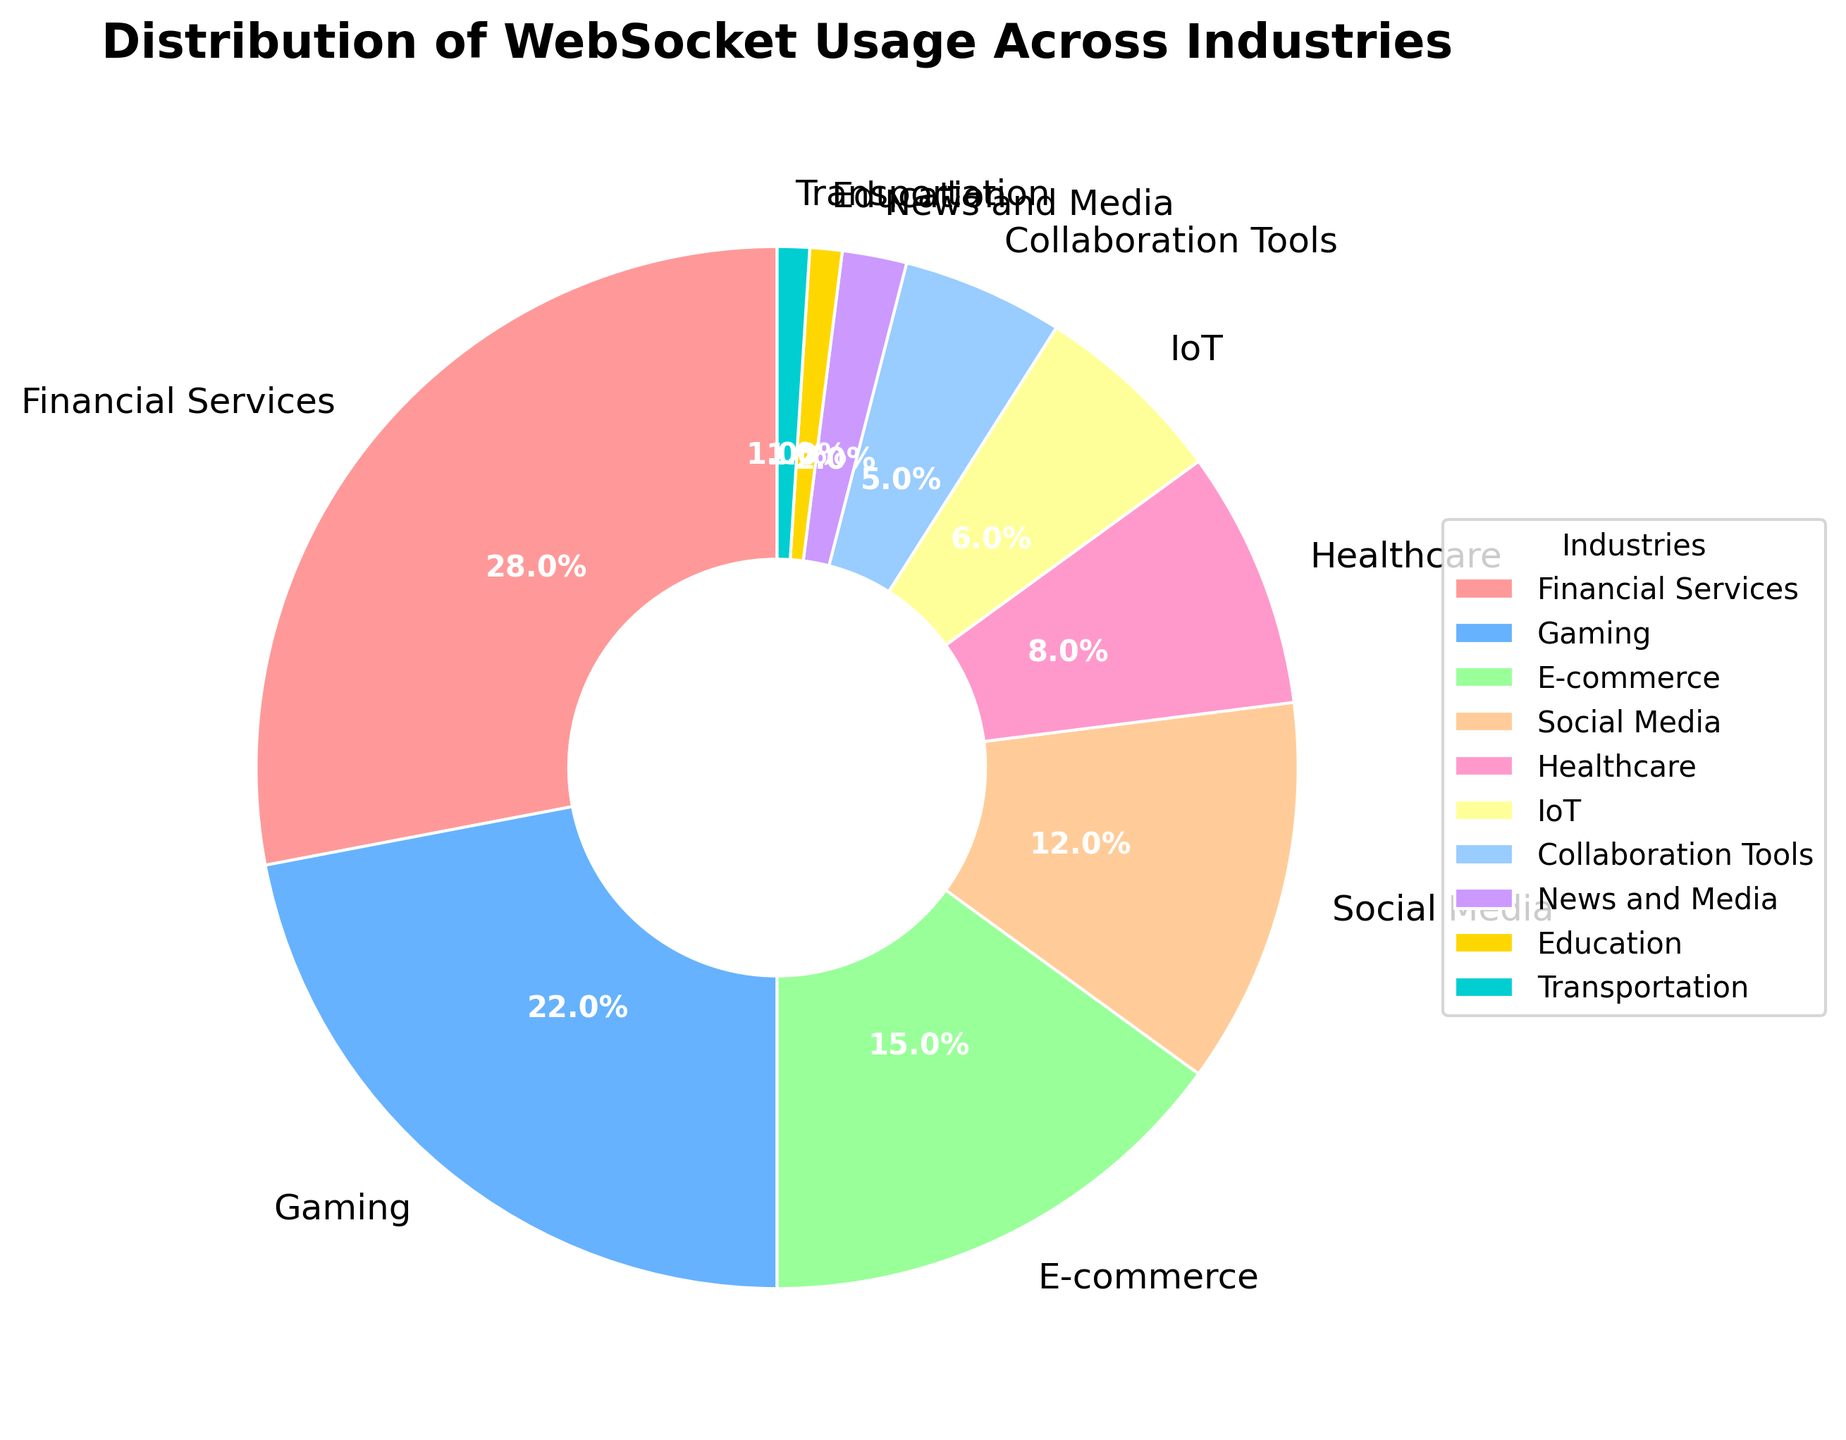What's the largest industry for WebSocket usage? To determine the largest industry, we look at the percentages in the pie chart. The highest percentage is 28%, which corresponds to Financial Services.
Answer: Financial Services Which industry shares the same percentage of WebSocket usage as IoT? IoT has a percentage of 6%. By scanning the pie chart, we see that no other industry shares exactly the same percentage as IoT.
Answer: None What's the combined WebSocket usage percentage for Social Media and E-commerce? Social Media usage is 12% and E-commerce usage is 15%. Adding these two percentages gives us 12% + 15% = 27%.
Answer: 27% Are there more industries with a WebSocket usage percentage below or above 10%? Industries below 10%: Healthcare, IoT, Collaboration Tools, News and Media, Education, and Transportation (6 industries). Industries above 10%: Financial Services, Gaming, E-commerce, Social Media (4 industries). There are more industries with usage below 10%.
Answer: Below Which industry uses WebSockets the least? The smallest percentage shown in the pie chart is 1%, which corresponds to both Education and Transportation.
Answer: Education and Transportation What's the difference in WebSocket usage between Gaming and Healthcare? Gaming has a WebSocket usage of 22% and Healthcare has 8%. The difference is calculated as 22% - 8% = 14%.
Answer: 14% Which industry has the second highest WebSocket usage? The industry with the highest usage is Financial Services at 28%. The second highest is Gaming at 22%.
Answer: Gaming What's the total percentage of the industries that use WebSockets for IoT, Collaboration Tools, and News and Media? IoT has 6%, Collaboration Tools have 5%, and News and Media have 2%. Adding these gives 6% + 5% + 2% = 13%.
Answer: 13% Which segment is the smallest in the pie chart by visual inspection? The smallest segment visually is the one with 1%, which corresponds to both Education and Transportation.
Answer: Education and Transportation Is E-commerce usage greater than the sum of Healthcare and IoT usage? E-commerce usage is 15%. Healthcare usage is 8% and IoT usage is 6%. Adding Healthcare and IoT gives 8% + 6% = 14%. Since 15% is greater than 14%, E-commerce usage is greater.
Answer: Yes 